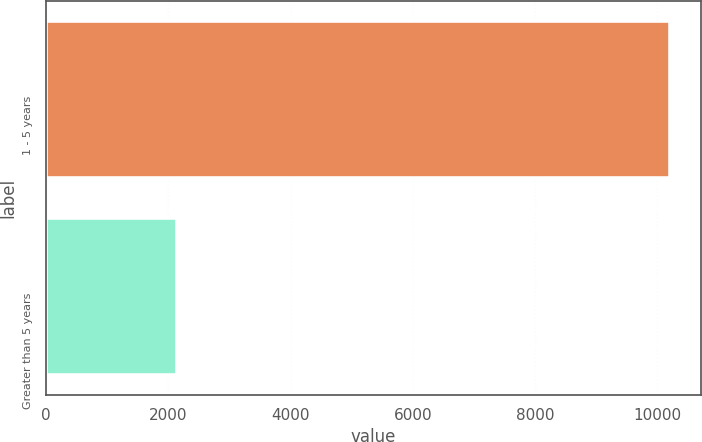Convert chart to OTSL. <chart><loc_0><loc_0><loc_500><loc_500><bar_chart><fcel>1 - 5 years<fcel>Greater than 5 years<nl><fcel>10201<fcel>2142<nl></chart> 